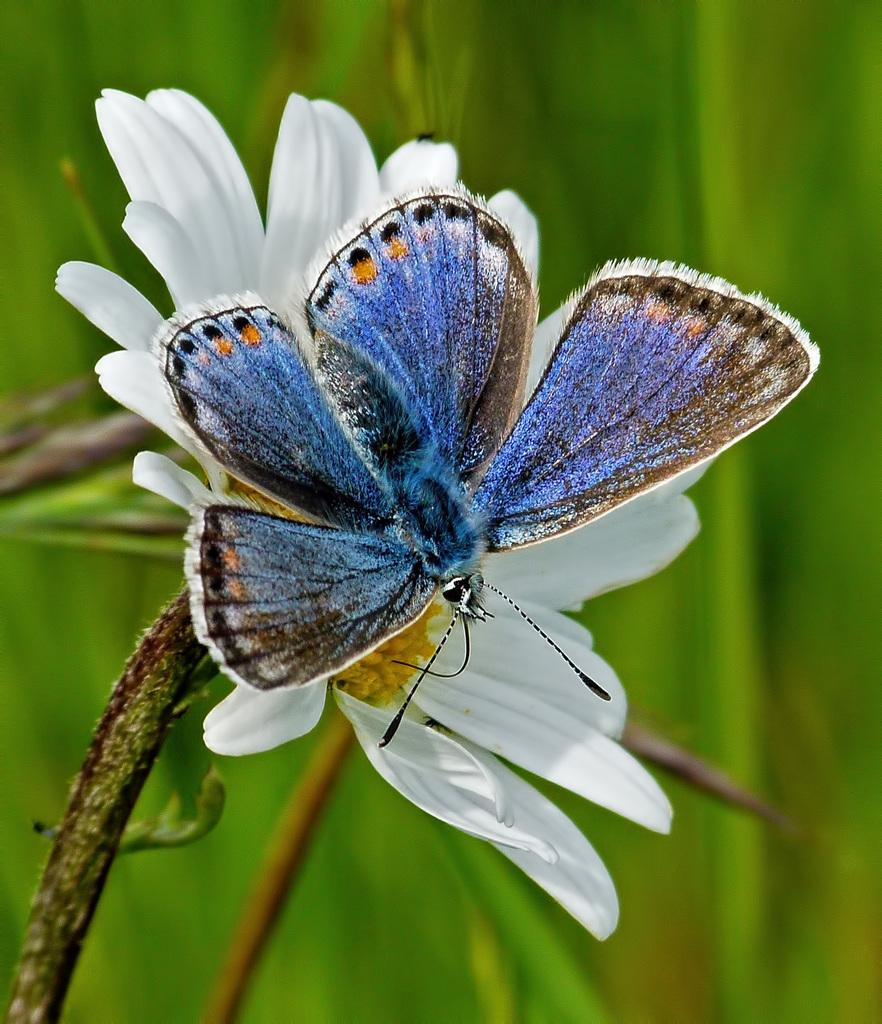What is the main subject of the image? There is an insect on a flower in the image. What can be seen in the background of the image? There is a plant visible in the background of the image. How would you describe the background of the image? The background of the image is blurry. What type of boot is the insect wearing in the image? There is no boot present in the image, as insects do not wear boots. 